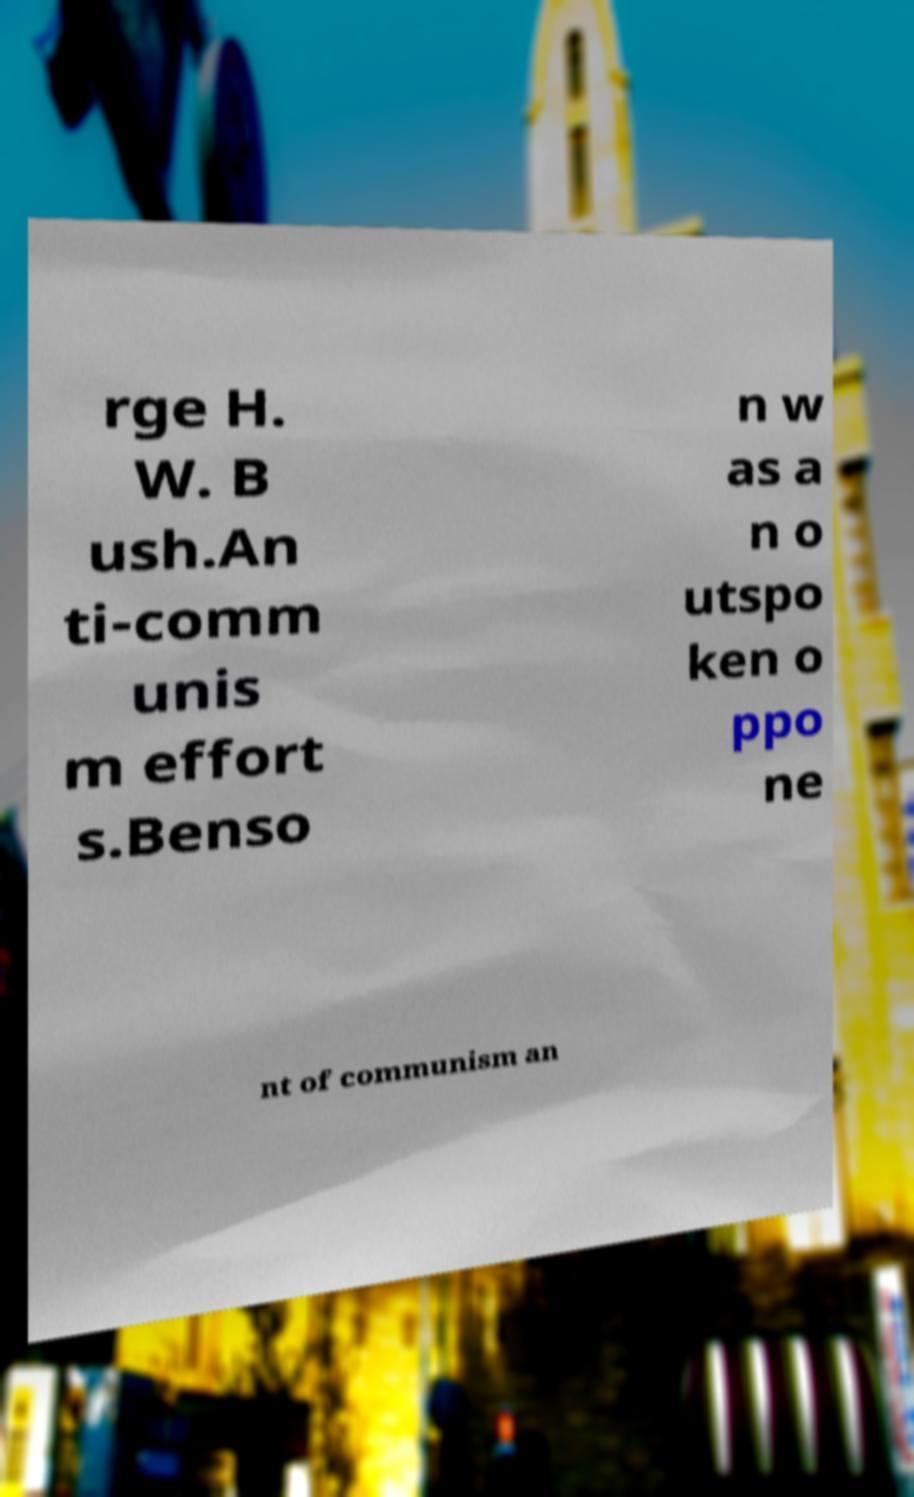Can you read and provide the text displayed in the image?This photo seems to have some interesting text. Can you extract and type it out for me? rge H. W. B ush.An ti-comm unis m effort s.Benso n w as a n o utspo ken o ppo ne nt of communism an 